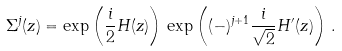<formula> <loc_0><loc_0><loc_500><loc_500>\Sigma ^ { j } ( z ) = \exp \left ( { \frac { i } { 2 } } H ( z ) \right ) \, \exp \left ( ( - ) ^ { j + 1 } { \frac { i } { \sqrt { 2 } } } { H ^ { \prime } } ( z ) \right ) \, .</formula> 